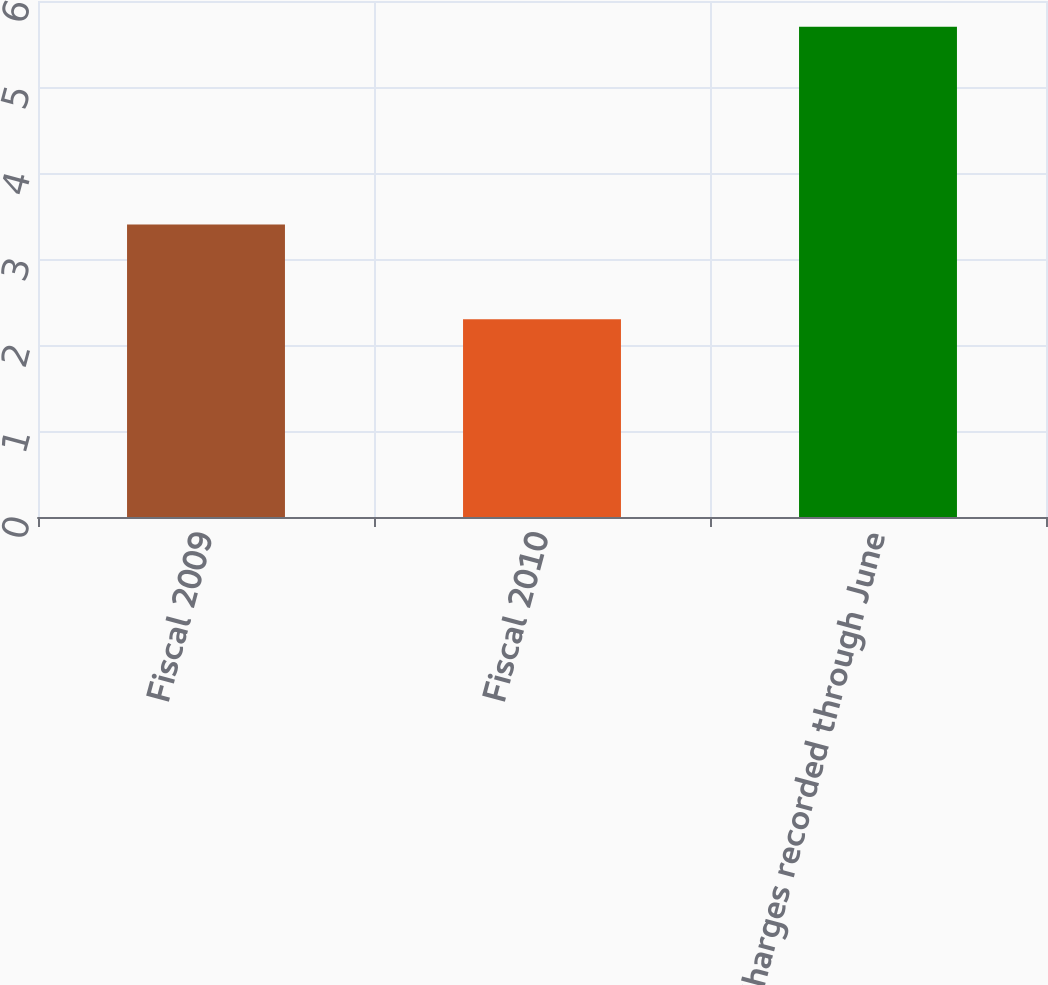<chart> <loc_0><loc_0><loc_500><loc_500><bar_chart><fcel>Fiscal 2009<fcel>Fiscal 2010<fcel>Charges recorded through June<nl><fcel>3.4<fcel>2.3<fcel>5.7<nl></chart> 